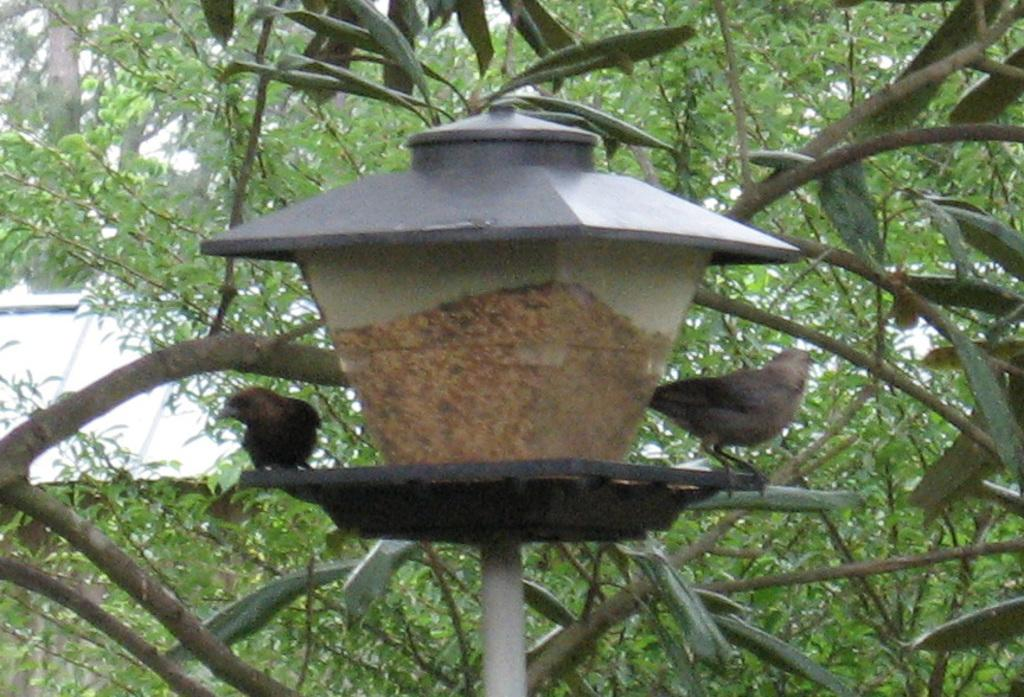What structure can be seen in the image? There is a light pole in the image. Are there any animals present on the light pole? Yes, there are two birds on the light pole. What can be seen in the background of the image? There are many leaves in the background of the image. What type of building is visible on the left side of the image? The roof of a house is visible on the left side of the image. What type of account is being discussed in the image? There is no account being discussed in the image; it features a light pole with birds and a background of leaves. Can you see any ants on the light pole in the image? There are no ants visible on the light pole in the image. 